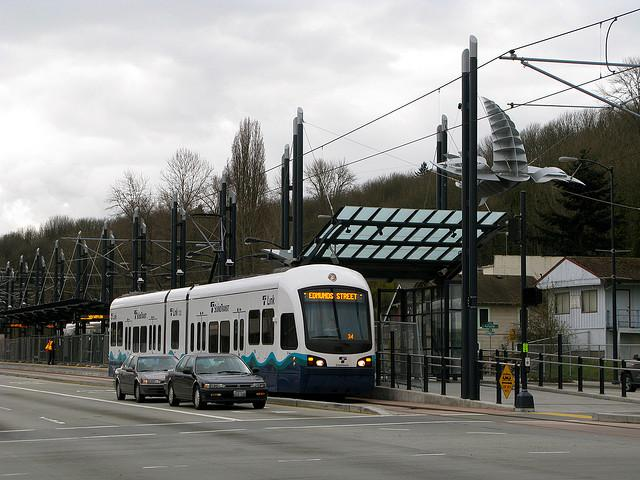What are white lines on road called? Please explain your reasoning. border line. The lines are border lines. 